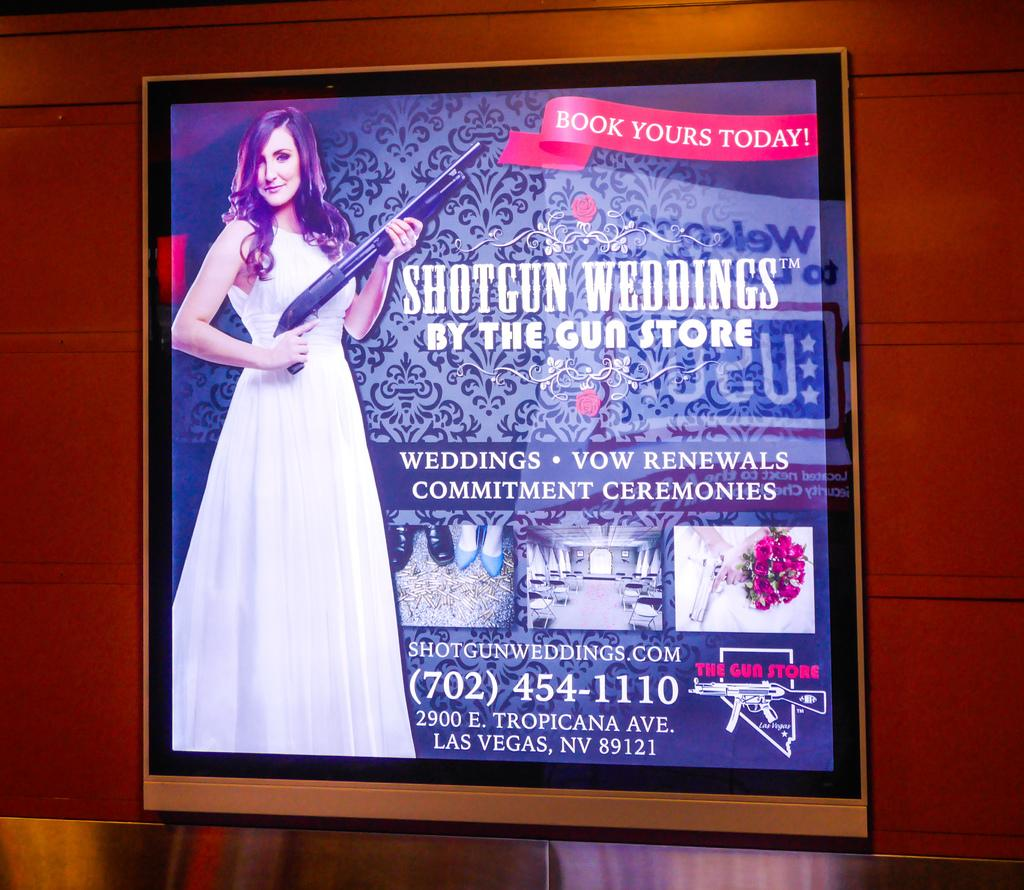What is the woman in the image holding? The woman is holding a gun in the image. What else can be seen in the image besides the woman and the gun? There is a group of photos, numbers, and text visible in the image. What is the background of the image? There is a wall in the background of the image. What type of pen is the toad using to write on the wall in the image? There is no toad or pen present in the image. Who is the father of the woman in the image? The provided facts do not mention any information about the woman's father, so it cannot be determined from the image. 